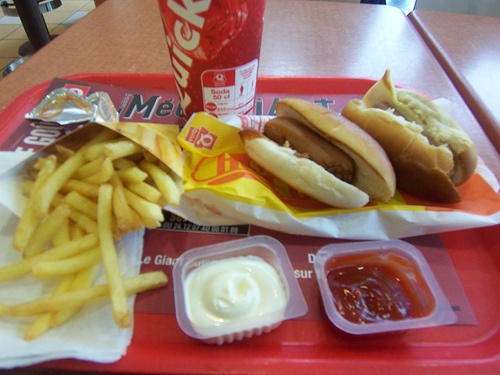Describe the objects in this image and their specific colors. I can see dining table in darkgray, brown, tan, and maroon tones, hot dog in gray, tan, maroon, and darkgray tones, cup in gray, brown, tan, and maroon tones, hot dog in gray, tan, maroon, and olive tones, and dining table in gray, lightblue, and darkgray tones in this image. 